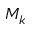<formula> <loc_0><loc_0><loc_500><loc_500>M _ { k }</formula> 